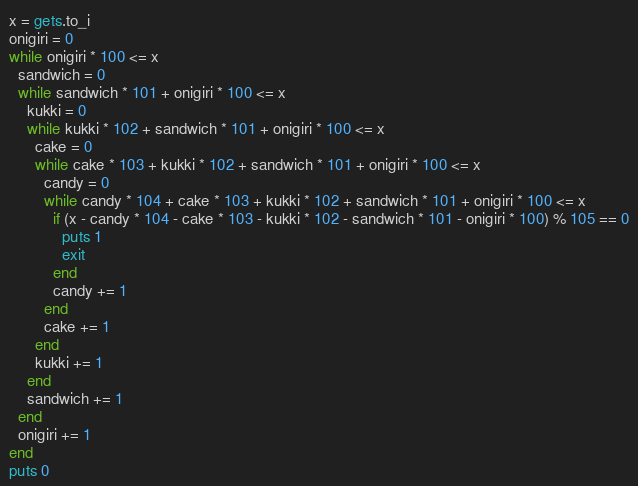Convert code to text. <code><loc_0><loc_0><loc_500><loc_500><_Ruby_>x = gets.to_i
onigiri = 0
while onigiri * 100 <= x
  sandwich = 0
  while sandwich * 101 + onigiri * 100 <= x
    kukki = 0
    while kukki * 102 + sandwich * 101 + onigiri * 100 <= x
      cake = 0
      while cake * 103 + kukki * 102 + sandwich * 101 + onigiri * 100 <= x
        candy = 0
        while candy * 104 + cake * 103 + kukki * 102 + sandwich * 101 + onigiri * 100 <= x
          if (x - candy * 104 - cake * 103 - kukki * 102 - sandwich * 101 - onigiri * 100) % 105 == 0
            puts 1
            exit
          end
          candy += 1
        end
        cake += 1
      end
      kukki += 1
    end
    sandwich += 1
  end
  onigiri += 1
end
puts 0</code> 